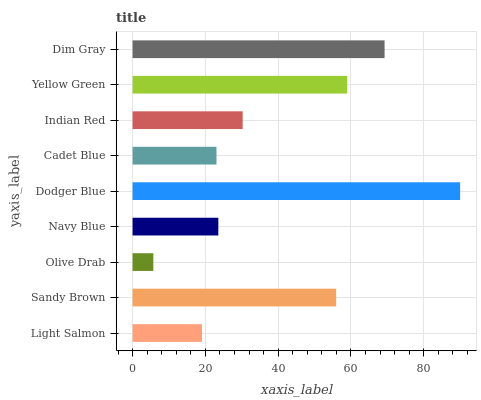Is Olive Drab the minimum?
Answer yes or no. Yes. Is Dodger Blue the maximum?
Answer yes or no. Yes. Is Sandy Brown the minimum?
Answer yes or no. No. Is Sandy Brown the maximum?
Answer yes or no. No. Is Sandy Brown greater than Light Salmon?
Answer yes or no. Yes. Is Light Salmon less than Sandy Brown?
Answer yes or no. Yes. Is Light Salmon greater than Sandy Brown?
Answer yes or no. No. Is Sandy Brown less than Light Salmon?
Answer yes or no. No. Is Indian Red the high median?
Answer yes or no. Yes. Is Indian Red the low median?
Answer yes or no. Yes. Is Olive Drab the high median?
Answer yes or no. No. Is Dodger Blue the low median?
Answer yes or no. No. 